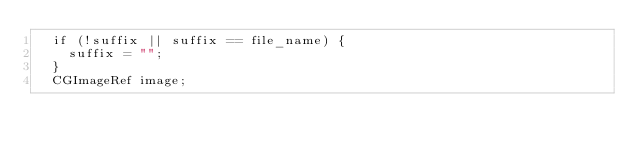<code> <loc_0><loc_0><loc_500><loc_500><_ObjectiveC_>  if (!suffix || suffix == file_name) {
    suffix = "";
  }
  CGImageRef image;</code> 